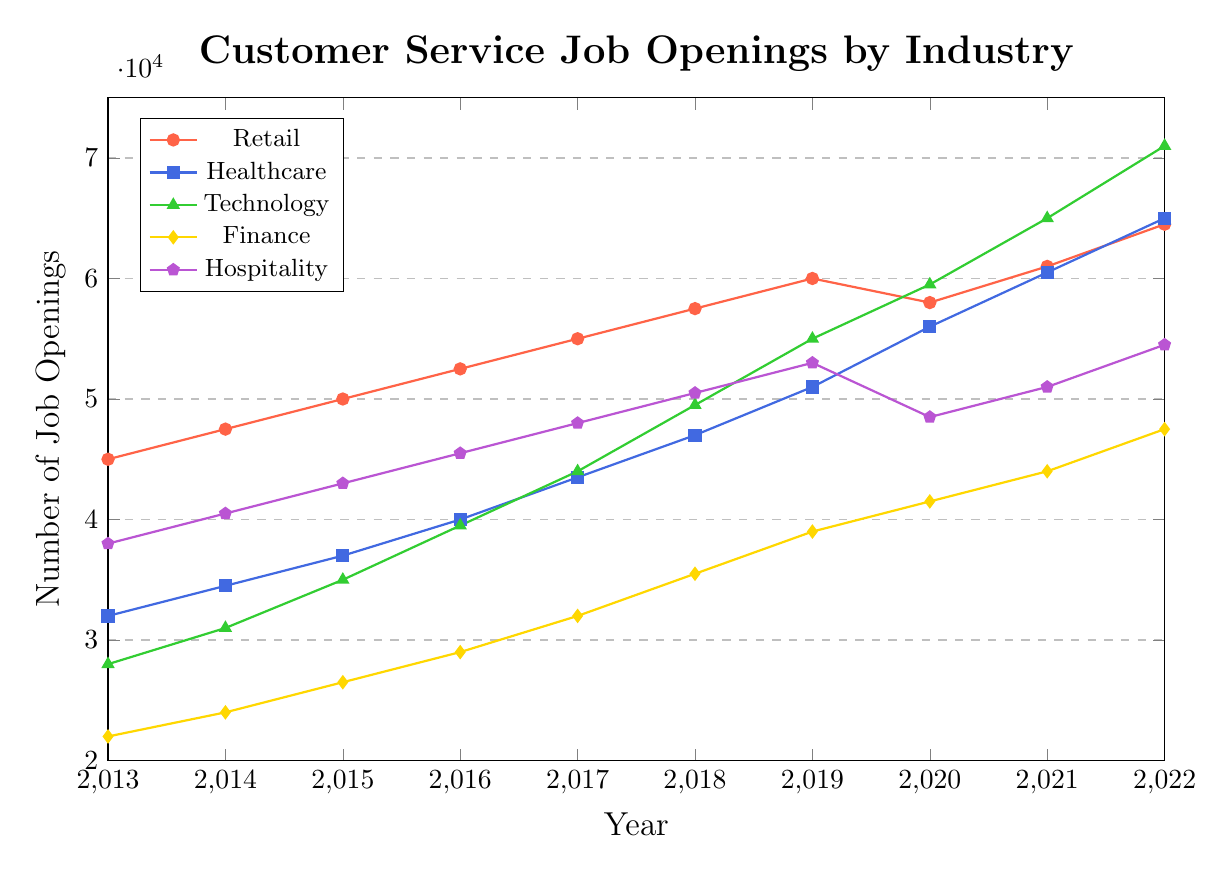Which industry had the highest number of customer service job openings in 2022? By looking at the highest data point in 2022, we see that the green line (Technology) is the highest.
Answer: Technology How did the job openings in the Finance industry change from 2013 to 2022? By comparing the job openings in Finance in 2013 (22000) and 2022 (47500), we see an increase of 47500 - 22000.
Answer: Increased by 25500 Which industry had the smallest increase in job openings from 2013 to 2022? By calculating the increase for each industry and comparing them, we find: Retail (19500), Healthcare (33000), Technology (43000), Finance (25500), Hospitality (16500). Hospitality had the smallest increase.
Answer: Hospitality What is the average number of job openings in the Retail industry from 2013 to 2022? The job openings are: 45000, 47500, 50000, 52500, 55000, 57500, 60000, 58000, 61000, 64500. The sum is 551000, and the average is 551000 / 10.
Answer: 55100 Between 2018 and 2019, which industry saw the highest growth in job openings? Calculating the growth for each industry: Retail (60000-57500=2500), Healthcare (51000-47000=4000), Technology (55000-49500=5500), Finance (39000-35500=3500), Hospitality (53000-50500=2500). Technology had the highest growth.
Answer: Technology Which industry experienced a decline in job openings between any two consecutive years? By examining the plot, only Retail experienced a decline from 2019 (60000) to 2020 (58000).
Answer: Retail How much higher were the job openings in Healthcare compared to Finance in 2022? Healthcare had 65000 job openings, and Finance had 47500 in 2022. The difference is 65000 - 47500.
Answer: 17500 What is the trend in Technology job openings over the past decade? The plot shows an increasing trend in Technology job openings, starting at 28000 in 2013 and rising to 71000 in 2022.
Answer: Increasing Which year saw the highest number of total job openings across all industries combined? Adding job openings for all industries for each year, 2022 has the highest sum: 64500 (Retail) + 65000 (Healthcare) + 71000 (Technology) + 47500 (Finance) + 54500 (Hospitality) = 302000.
Answer: 2022 In which year did the Hospitality industry have fewer job openings compared to the previous year? From 2019 (53000) to 2020 (48500), Hospitality experienced a decline in job openings.
Answer: 2020 